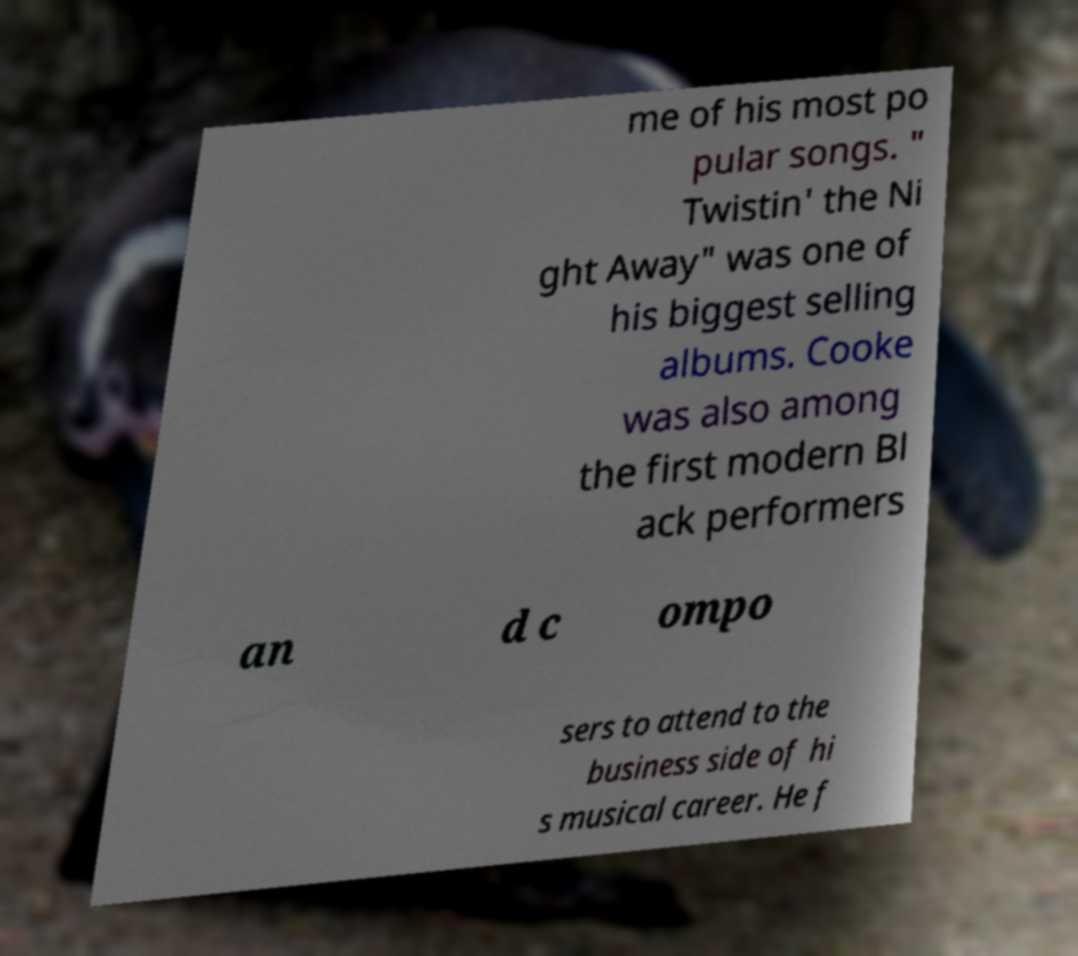Please read and relay the text visible in this image. What does it say? me of his most po pular songs. " Twistin' the Ni ght Away" was one of his biggest selling albums. Cooke was also among the first modern Bl ack performers an d c ompo sers to attend to the business side of hi s musical career. He f 